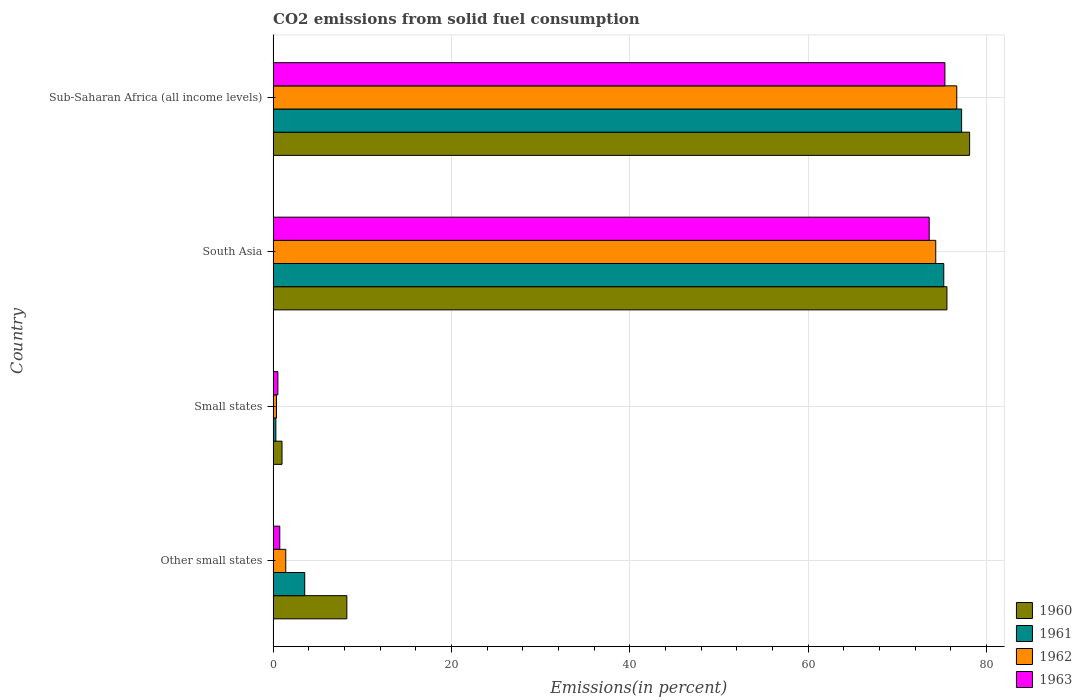How many different coloured bars are there?
Give a very brief answer. 4. How many groups of bars are there?
Your response must be concise. 4. Are the number of bars on each tick of the Y-axis equal?
Give a very brief answer. Yes. What is the total CO2 emitted in 1962 in Small states?
Keep it short and to the point. 0.38. Across all countries, what is the maximum total CO2 emitted in 1961?
Your answer should be very brief. 77.23. Across all countries, what is the minimum total CO2 emitted in 1960?
Your response must be concise. 1. In which country was the total CO2 emitted in 1963 maximum?
Your response must be concise. Sub-Saharan Africa (all income levels). In which country was the total CO2 emitted in 1963 minimum?
Your answer should be very brief. Small states. What is the total total CO2 emitted in 1963 in the graph?
Provide a succinct answer. 150.23. What is the difference between the total CO2 emitted in 1960 in Other small states and that in Sub-Saharan Africa (all income levels)?
Offer a terse response. -69.86. What is the difference between the total CO2 emitted in 1962 in South Asia and the total CO2 emitted in 1963 in Small states?
Keep it short and to the point. 73.8. What is the average total CO2 emitted in 1962 per country?
Provide a succinct answer. 38.2. What is the difference between the total CO2 emitted in 1963 and total CO2 emitted in 1961 in Small states?
Offer a very short reply. 0.23. In how many countries, is the total CO2 emitted in 1962 greater than 8 %?
Provide a succinct answer. 2. What is the ratio of the total CO2 emitted in 1962 in Small states to that in South Asia?
Offer a very short reply. 0.01. Is the total CO2 emitted in 1962 in Small states less than that in Sub-Saharan Africa (all income levels)?
Your answer should be very brief. Yes. Is the difference between the total CO2 emitted in 1963 in Other small states and Sub-Saharan Africa (all income levels) greater than the difference between the total CO2 emitted in 1961 in Other small states and Sub-Saharan Africa (all income levels)?
Your answer should be very brief. No. What is the difference between the highest and the second highest total CO2 emitted in 1962?
Provide a short and direct response. 2.36. What is the difference between the highest and the lowest total CO2 emitted in 1963?
Provide a short and direct response. 74.82. What does the 2nd bar from the top in Sub-Saharan Africa (all income levels) represents?
Your answer should be very brief. 1962. What does the 4th bar from the bottom in Sub-Saharan Africa (all income levels) represents?
Your response must be concise. 1963. How many bars are there?
Provide a succinct answer. 16. Are all the bars in the graph horizontal?
Your answer should be compact. Yes. How many countries are there in the graph?
Give a very brief answer. 4. What is the difference between two consecutive major ticks on the X-axis?
Your answer should be compact. 20. Does the graph contain any zero values?
Your answer should be very brief. No. Does the graph contain grids?
Provide a short and direct response. Yes. Where does the legend appear in the graph?
Offer a terse response. Bottom right. How are the legend labels stacked?
Provide a short and direct response. Vertical. What is the title of the graph?
Keep it short and to the point. CO2 emissions from solid fuel consumption. What is the label or title of the X-axis?
Your response must be concise. Emissions(in percent). What is the Emissions(in percent) of 1960 in Other small states?
Make the answer very short. 8.27. What is the Emissions(in percent) in 1961 in Other small states?
Provide a succinct answer. 3.55. What is the Emissions(in percent) of 1962 in Other small states?
Offer a very short reply. 1.42. What is the Emissions(in percent) of 1963 in Other small states?
Your answer should be very brief. 0.75. What is the Emissions(in percent) of 1960 in Small states?
Give a very brief answer. 1. What is the Emissions(in percent) of 1961 in Small states?
Keep it short and to the point. 0.31. What is the Emissions(in percent) of 1962 in Small states?
Offer a very short reply. 0.38. What is the Emissions(in percent) of 1963 in Small states?
Your answer should be compact. 0.53. What is the Emissions(in percent) in 1960 in South Asia?
Keep it short and to the point. 75.58. What is the Emissions(in percent) of 1961 in South Asia?
Your answer should be compact. 75.23. What is the Emissions(in percent) in 1962 in South Asia?
Your answer should be compact. 74.33. What is the Emissions(in percent) of 1963 in South Asia?
Provide a succinct answer. 73.59. What is the Emissions(in percent) in 1960 in Sub-Saharan Africa (all income levels)?
Provide a short and direct response. 78.13. What is the Emissions(in percent) of 1961 in Sub-Saharan Africa (all income levels)?
Offer a terse response. 77.23. What is the Emissions(in percent) of 1962 in Sub-Saharan Africa (all income levels)?
Your answer should be very brief. 76.69. What is the Emissions(in percent) of 1963 in Sub-Saharan Africa (all income levels)?
Your answer should be compact. 75.35. Across all countries, what is the maximum Emissions(in percent) of 1960?
Offer a very short reply. 78.13. Across all countries, what is the maximum Emissions(in percent) of 1961?
Ensure brevity in your answer.  77.23. Across all countries, what is the maximum Emissions(in percent) of 1962?
Your answer should be compact. 76.69. Across all countries, what is the maximum Emissions(in percent) of 1963?
Your answer should be compact. 75.35. Across all countries, what is the minimum Emissions(in percent) in 1960?
Your answer should be very brief. 1. Across all countries, what is the minimum Emissions(in percent) of 1961?
Offer a very short reply. 0.31. Across all countries, what is the minimum Emissions(in percent) of 1962?
Offer a terse response. 0.38. Across all countries, what is the minimum Emissions(in percent) of 1963?
Your response must be concise. 0.53. What is the total Emissions(in percent) in 1960 in the graph?
Your answer should be very brief. 162.98. What is the total Emissions(in percent) in 1961 in the graph?
Provide a succinct answer. 156.31. What is the total Emissions(in percent) of 1962 in the graph?
Make the answer very short. 152.81. What is the total Emissions(in percent) of 1963 in the graph?
Offer a terse response. 150.23. What is the difference between the Emissions(in percent) of 1960 in Other small states and that in Small states?
Make the answer very short. 7.27. What is the difference between the Emissions(in percent) of 1961 in Other small states and that in Small states?
Your answer should be compact. 3.24. What is the difference between the Emissions(in percent) in 1962 in Other small states and that in Small states?
Offer a terse response. 1.04. What is the difference between the Emissions(in percent) of 1963 in Other small states and that in Small states?
Provide a short and direct response. 0.21. What is the difference between the Emissions(in percent) in 1960 in Other small states and that in South Asia?
Keep it short and to the point. -67.31. What is the difference between the Emissions(in percent) in 1961 in Other small states and that in South Asia?
Your response must be concise. -71.68. What is the difference between the Emissions(in percent) in 1962 in Other small states and that in South Asia?
Your answer should be compact. -72.91. What is the difference between the Emissions(in percent) of 1963 in Other small states and that in South Asia?
Your response must be concise. -72.85. What is the difference between the Emissions(in percent) of 1960 in Other small states and that in Sub-Saharan Africa (all income levels)?
Make the answer very short. -69.86. What is the difference between the Emissions(in percent) in 1961 in Other small states and that in Sub-Saharan Africa (all income levels)?
Provide a succinct answer. -73.68. What is the difference between the Emissions(in percent) in 1962 in Other small states and that in Sub-Saharan Africa (all income levels)?
Keep it short and to the point. -75.27. What is the difference between the Emissions(in percent) of 1963 in Other small states and that in Sub-Saharan Africa (all income levels)?
Provide a short and direct response. -74.61. What is the difference between the Emissions(in percent) in 1960 in Small states and that in South Asia?
Your answer should be compact. -74.58. What is the difference between the Emissions(in percent) of 1961 in Small states and that in South Asia?
Your answer should be very brief. -74.92. What is the difference between the Emissions(in percent) of 1962 in Small states and that in South Asia?
Your answer should be compact. -73.95. What is the difference between the Emissions(in percent) of 1963 in Small states and that in South Asia?
Keep it short and to the point. -73.06. What is the difference between the Emissions(in percent) in 1960 in Small states and that in Sub-Saharan Africa (all income levels)?
Offer a terse response. -77.13. What is the difference between the Emissions(in percent) of 1961 in Small states and that in Sub-Saharan Africa (all income levels)?
Offer a terse response. -76.92. What is the difference between the Emissions(in percent) in 1962 in Small states and that in Sub-Saharan Africa (all income levels)?
Offer a very short reply. -76.31. What is the difference between the Emissions(in percent) of 1963 in Small states and that in Sub-Saharan Africa (all income levels)?
Your response must be concise. -74.82. What is the difference between the Emissions(in percent) of 1960 in South Asia and that in Sub-Saharan Africa (all income levels)?
Provide a short and direct response. -2.54. What is the difference between the Emissions(in percent) in 1961 in South Asia and that in Sub-Saharan Africa (all income levels)?
Offer a terse response. -2. What is the difference between the Emissions(in percent) in 1962 in South Asia and that in Sub-Saharan Africa (all income levels)?
Your answer should be compact. -2.36. What is the difference between the Emissions(in percent) in 1963 in South Asia and that in Sub-Saharan Africa (all income levels)?
Make the answer very short. -1.76. What is the difference between the Emissions(in percent) in 1960 in Other small states and the Emissions(in percent) in 1961 in Small states?
Your answer should be compact. 7.96. What is the difference between the Emissions(in percent) in 1960 in Other small states and the Emissions(in percent) in 1962 in Small states?
Your answer should be very brief. 7.89. What is the difference between the Emissions(in percent) of 1960 in Other small states and the Emissions(in percent) of 1963 in Small states?
Keep it short and to the point. 7.74. What is the difference between the Emissions(in percent) in 1961 in Other small states and the Emissions(in percent) in 1962 in Small states?
Provide a succinct answer. 3.17. What is the difference between the Emissions(in percent) of 1961 in Other small states and the Emissions(in percent) of 1963 in Small states?
Your response must be concise. 3.01. What is the difference between the Emissions(in percent) in 1962 in Other small states and the Emissions(in percent) in 1963 in Small states?
Your response must be concise. 0.88. What is the difference between the Emissions(in percent) of 1960 in Other small states and the Emissions(in percent) of 1961 in South Asia?
Your answer should be compact. -66.96. What is the difference between the Emissions(in percent) in 1960 in Other small states and the Emissions(in percent) in 1962 in South Asia?
Offer a terse response. -66.06. What is the difference between the Emissions(in percent) in 1960 in Other small states and the Emissions(in percent) in 1963 in South Asia?
Provide a succinct answer. -65.32. What is the difference between the Emissions(in percent) of 1961 in Other small states and the Emissions(in percent) of 1962 in South Asia?
Your response must be concise. -70.78. What is the difference between the Emissions(in percent) of 1961 in Other small states and the Emissions(in percent) of 1963 in South Asia?
Your answer should be very brief. -70.05. What is the difference between the Emissions(in percent) of 1962 in Other small states and the Emissions(in percent) of 1963 in South Asia?
Offer a very short reply. -72.17. What is the difference between the Emissions(in percent) of 1960 in Other small states and the Emissions(in percent) of 1961 in Sub-Saharan Africa (all income levels)?
Give a very brief answer. -68.96. What is the difference between the Emissions(in percent) of 1960 in Other small states and the Emissions(in percent) of 1962 in Sub-Saharan Africa (all income levels)?
Make the answer very short. -68.42. What is the difference between the Emissions(in percent) in 1960 in Other small states and the Emissions(in percent) in 1963 in Sub-Saharan Africa (all income levels)?
Provide a succinct answer. -67.08. What is the difference between the Emissions(in percent) of 1961 in Other small states and the Emissions(in percent) of 1962 in Sub-Saharan Africa (all income levels)?
Provide a succinct answer. -73.14. What is the difference between the Emissions(in percent) of 1961 in Other small states and the Emissions(in percent) of 1963 in Sub-Saharan Africa (all income levels)?
Offer a terse response. -71.81. What is the difference between the Emissions(in percent) of 1962 in Other small states and the Emissions(in percent) of 1963 in Sub-Saharan Africa (all income levels)?
Provide a succinct answer. -73.94. What is the difference between the Emissions(in percent) in 1960 in Small states and the Emissions(in percent) in 1961 in South Asia?
Make the answer very short. -74.23. What is the difference between the Emissions(in percent) of 1960 in Small states and the Emissions(in percent) of 1962 in South Asia?
Offer a terse response. -73.33. What is the difference between the Emissions(in percent) in 1960 in Small states and the Emissions(in percent) in 1963 in South Asia?
Offer a terse response. -72.59. What is the difference between the Emissions(in percent) in 1961 in Small states and the Emissions(in percent) in 1962 in South Asia?
Give a very brief answer. -74.02. What is the difference between the Emissions(in percent) of 1961 in Small states and the Emissions(in percent) of 1963 in South Asia?
Keep it short and to the point. -73.29. What is the difference between the Emissions(in percent) in 1962 in Small states and the Emissions(in percent) in 1963 in South Asia?
Provide a succinct answer. -73.22. What is the difference between the Emissions(in percent) in 1960 in Small states and the Emissions(in percent) in 1961 in Sub-Saharan Africa (all income levels)?
Ensure brevity in your answer.  -76.23. What is the difference between the Emissions(in percent) of 1960 in Small states and the Emissions(in percent) of 1962 in Sub-Saharan Africa (all income levels)?
Make the answer very short. -75.69. What is the difference between the Emissions(in percent) in 1960 in Small states and the Emissions(in percent) in 1963 in Sub-Saharan Africa (all income levels)?
Your answer should be compact. -74.36. What is the difference between the Emissions(in percent) in 1961 in Small states and the Emissions(in percent) in 1962 in Sub-Saharan Africa (all income levels)?
Your answer should be very brief. -76.38. What is the difference between the Emissions(in percent) in 1961 in Small states and the Emissions(in percent) in 1963 in Sub-Saharan Africa (all income levels)?
Provide a short and direct response. -75.05. What is the difference between the Emissions(in percent) of 1962 in Small states and the Emissions(in percent) of 1963 in Sub-Saharan Africa (all income levels)?
Keep it short and to the point. -74.98. What is the difference between the Emissions(in percent) of 1960 in South Asia and the Emissions(in percent) of 1961 in Sub-Saharan Africa (all income levels)?
Make the answer very short. -1.65. What is the difference between the Emissions(in percent) of 1960 in South Asia and the Emissions(in percent) of 1962 in Sub-Saharan Africa (all income levels)?
Offer a terse response. -1.1. What is the difference between the Emissions(in percent) of 1960 in South Asia and the Emissions(in percent) of 1963 in Sub-Saharan Africa (all income levels)?
Your answer should be compact. 0.23. What is the difference between the Emissions(in percent) in 1961 in South Asia and the Emissions(in percent) in 1962 in Sub-Saharan Africa (all income levels)?
Your answer should be compact. -1.46. What is the difference between the Emissions(in percent) of 1961 in South Asia and the Emissions(in percent) of 1963 in Sub-Saharan Africa (all income levels)?
Your answer should be compact. -0.13. What is the difference between the Emissions(in percent) in 1962 in South Asia and the Emissions(in percent) in 1963 in Sub-Saharan Africa (all income levels)?
Ensure brevity in your answer.  -1.03. What is the average Emissions(in percent) of 1960 per country?
Your answer should be compact. 40.74. What is the average Emissions(in percent) in 1961 per country?
Offer a terse response. 39.08. What is the average Emissions(in percent) of 1962 per country?
Your answer should be very brief. 38.2. What is the average Emissions(in percent) of 1963 per country?
Offer a terse response. 37.56. What is the difference between the Emissions(in percent) of 1960 and Emissions(in percent) of 1961 in Other small states?
Your answer should be compact. 4.72. What is the difference between the Emissions(in percent) in 1960 and Emissions(in percent) in 1962 in Other small states?
Your answer should be compact. 6.85. What is the difference between the Emissions(in percent) in 1960 and Emissions(in percent) in 1963 in Other small states?
Provide a short and direct response. 7.52. What is the difference between the Emissions(in percent) in 1961 and Emissions(in percent) in 1962 in Other small states?
Ensure brevity in your answer.  2.13. What is the difference between the Emissions(in percent) of 1961 and Emissions(in percent) of 1963 in Other small states?
Provide a succinct answer. 2.8. What is the difference between the Emissions(in percent) of 1962 and Emissions(in percent) of 1963 in Other small states?
Ensure brevity in your answer.  0.67. What is the difference between the Emissions(in percent) in 1960 and Emissions(in percent) in 1961 in Small states?
Make the answer very short. 0.69. What is the difference between the Emissions(in percent) in 1960 and Emissions(in percent) in 1962 in Small states?
Provide a succinct answer. 0.62. What is the difference between the Emissions(in percent) in 1960 and Emissions(in percent) in 1963 in Small states?
Give a very brief answer. 0.46. What is the difference between the Emissions(in percent) in 1961 and Emissions(in percent) in 1962 in Small states?
Your answer should be compact. -0.07. What is the difference between the Emissions(in percent) in 1961 and Emissions(in percent) in 1963 in Small states?
Provide a short and direct response. -0.23. What is the difference between the Emissions(in percent) of 1962 and Emissions(in percent) of 1963 in Small states?
Keep it short and to the point. -0.16. What is the difference between the Emissions(in percent) in 1960 and Emissions(in percent) in 1961 in South Asia?
Provide a succinct answer. 0.36. What is the difference between the Emissions(in percent) in 1960 and Emissions(in percent) in 1962 in South Asia?
Offer a terse response. 1.25. What is the difference between the Emissions(in percent) in 1960 and Emissions(in percent) in 1963 in South Asia?
Offer a very short reply. 1.99. What is the difference between the Emissions(in percent) of 1961 and Emissions(in percent) of 1962 in South Asia?
Keep it short and to the point. 0.9. What is the difference between the Emissions(in percent) in 1961 and Emissions(in percent) in 1963 in South Asia?
Keep it short and to the point. 1.63. What is the difference between the Emissions(in percent) in 1962 and Emissions(in percent) in 1963 in South Asia?
Keep it short and to the point. 0.74. What is the difference between the Emissions(in percent) in 1960 and Emissions(in percent) in 1961 in Sub-Saharan Africa (all income levels)?
Provide a short and direct response. 0.9. What is the difference between the Emissions(in percent) in 1960 and Emissions(in percent) in 1962 in Sub-Saharan Africa (all income levels)?
Your answer should be very brief. 1.44. What is the difference between the Emissions(in percent) of 1960 and Emissions(in percent) of 1963 in Sub-Saharan Africa (all income levels)?
Make the answer very short. 2.77. What is the difference between the Emissions(in percent) in 1961 and Emissions(in percent) in 1962 in Sub-Saharan Africa (all income levels)?
Offer a very short reply. 0.54. What is the difference between the Emissions(in percent) in 1961 and Emissions(in percent) in 1963 in Sub-Saharan Africa (all income levels)?
Make the answer very short. 1.88. What is the difference between the Emissions(in percent) in 1962 and Emissions(in percent) in 1963 in Sub-Saharan Africa (all income levels)?
Give a very brief answer. 1.33. What is the ratio of the Emissions(in percent) of 1960 in Other small states to that in Small states?
Ensure brevity in your answer.  8.28. What is the ratio of the Emissions(in percent) of 1961 in Other small states to that in Small states?
Your response must be concise. 11.6. What is the ratio of the Emissions(in percent) of 1962 in Other small states to that in Small states?
Give a very brief answer. 3.77. What is the ratio of the Emissions(in percent) of 1963 in Other small states to that in Small states?
Make the answer very short. 1.4. What is the ratio of the Emissions(in percent) of 1960 in Other small states to that in South Asia?
Ensure brevity in your answer.  0.11. What is the ratio of the Emissions(in percent) in 1961 in Other small states to that in South Asia?
Ensure brevity in your answer.  0.05. What is the ratio of the Emissions(in percent) of 1962 in Other small states to that in South Asia?
Ensure brevity in your answer.  0.02. What is the ratio of the Emissions(in percent) of 1963 in Other small states to that in South Asia?
Provide a succinct answer. 0.01. What is the ratio of the Emissions(in percent) in 1960 in Other small states to that in Sub-Saharan Africa (all income levels)?
Offer a very short reply. 0.11. What is the ratio of the Emissions(in percent) of 1961 in Other small states to that in Sub-Saharan Africa (all income levels)?
Offer a terse response. 0.05. What is the ratio of the Emissions(in percent) of 1962 in Other small states to that in Sub-Saharan Africa (all income levels)?
Keep it short and to the point. 0.02. What is the ratio of the Emissions(in percent) of 1963 in Other small states to that in Sub-Saharan Africa (all income levels)?
Your answer should be compact. 0.01. What is the ratio of the Emissions(in percent) of 1960 in Small states to that in South Asia?
Ensure brevity in your answer.  0.01. What is the ratio of the Emissions(in percent) of 1961 in Small states to that in South Asia?
Offer a terse response. 0. What is the ratio of the Emissions(in percent) in 1962 in Small states to that in South Asia?
Offer a terse response. 0.01. What is the ratio of the Emissions(in percent) in 1963 in Small states to that in South Asia?
Keep it short and to the point. 0.01. What is the ratio of the Emissions(in percent) in 1960 in Small states to that in Sub-Saharan Africa (all income levels)?
Provide a short and direct response. 0.01. What is the ratio of the Emissions(in percent) in 1961 in Small states to that in Sub-Saharan Africa (all income levels)?
Offer a terse response. 0. What is the ratio of the Emissions(in percent) of 1962 in Small states to that in Sub-Saharan Africa (all income levels)?
Offer a very short reply. 0. What is the ratio of the Emissions(in percent) in 1963 in Small states to that in Sub-Saharan Africa (all income levels)?
Provide a short and direct response. 0.01. What is the ratio of the Emissions(in percent) of 1960 in South Asia to that in Sub-Saharan Africa (all income levels)?
Provide a short and direct response. 0.97. What is the ratio of the Emissions(in percent) of 1961 in South Asia to that in Sub-Saharan Africa (all income levels)?
Your answer should be very brief. 0.97. What is the ratio of the Emissions(in percent) in 1962 in South Asia to that in Sub-Saharan Africa (all income levels)?
Ensure brevity in your answer.  0.97. What is the ratio of the Emissions(in percent) in 1963 in South Asia to that in Sub-Saharan Africa (all income levels)?
Offer a very short reply. 0.98. What is the difference between the highest and the second highest Emissions(in percent) of 1960?
Give a very brief answer. 2.54. What is the difference between the highest and the second highest Emissions(in percent) of 1961?
Offer a terse response. 2. What is the difference between the highest and the second highest Emissions(in percent) in 1962?
Provide a short and direct response. 2.36. What is the difference between the highest and the second highest Emissions(in percent) in 1963?
Offer a very short reply. 1.76. What is the difference between the highest and the lowest Emissions(in percent) in 1960?
Your answer should be very brief. 77.13. What is the difference between the highest and the lowest Emissions(in percent) of 1961?
Your response must be concise. 76.92. What is the difference between the highest and the lowest Emissions(in percent) in 1962?
Make the answer very short. 76.31. What is the difference between the highest and the lowest Emissions(in percent) in 1963?
Your answer should be very brief. 74.82. 